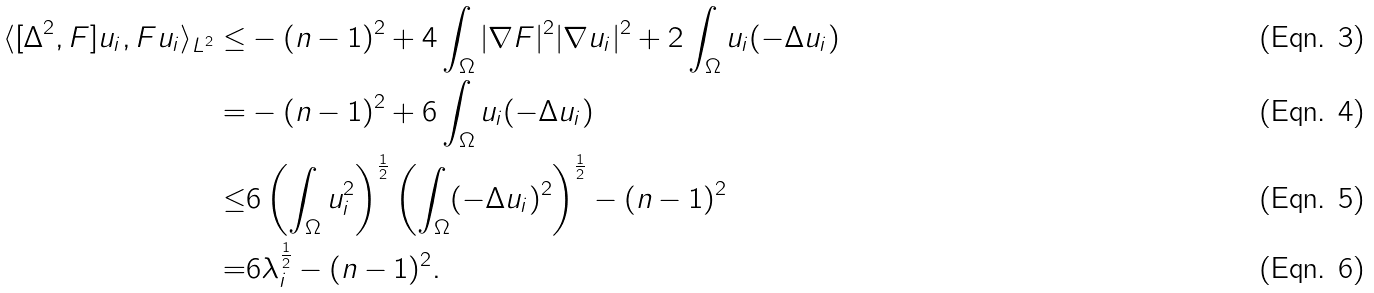Convert formula to latex. <formula><loc_0><loc_0><loc_500><loc_500>\langle [ \Delta ^ { 2 } , F ] u _ { i } , F u _ { i } \rangle _ { L ^ { 2 } } \leq & - ( n - 1 ) ^ { 2 } + 4 \int _ { \Omega } | \nabla F | ^ { 2 } | \nabla u _ { i } | ^ { 2 } + 2 \int _ { \Omega } u _ { i } ( - \Delta u _ { i } ) \\ = & - ( n - 1 ) ^ { 2 } + 6 \int _ { \Omega } u _ { i } ( - \Delta u _ { i } ) \\ \leq & 6 \left ( \int _ { \Omega } u _ { i } ^ { 2 } \right ) ^ { \frac { 1 } { 2 } } \left ( \int _ { \Omega } ( - \Delta u _ { i } ) ^ { 2 } \right ) ^ { \frac { 1 } { 2 } } - ( n - 1 ) ^ { 2 } \\ = & 6 \lambda _ { i } ^ { \frac { 1 } { 2 } } - ( n - 1 ) ^ { 2 } .</formula> 